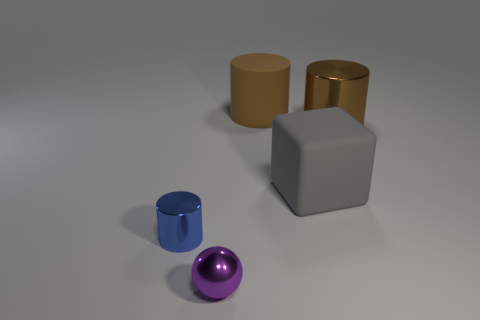What is the material of the large object that is both left of the large shiny thing and to the right of the large brown rubber cylinder?
Ensure brevity in your answer.  Rubber. Is the number of metal things in front of the metal ball less than the number of purple things that are in front of the tiny blue shiny thing?
Ensure brevity in your answer.  Yes. How many other objects are the same size as the brown metal cylinder?
Keep it short and to the point. 2. What shape is the matte thing in front of the thing behind the large object that is to the right of the big gray matte thing?
Make the answer very short. Cube. What number of purple objects are either large cylinders or metallic balls?
Your response must be concise. 1. There is a metal cylinder behind the blue shiny thing; what number of big matte things are behind it?
Keep it short and to the point. 1. Is there any other thing that is the same color as the large matte cube?
Provide a short and direct response. No. What shape is the blue thing that is made of the same material as the tiny ball?
Your answer should be very brief. Cylinder. Do the matte cylinder and the big metallic object have the same color?
Ensure brevity in your answer.  Yes. Is the large thing that is to the left of the big rubber block made of the same material as the thing left of the purple object?
Offer a terse response. No. 